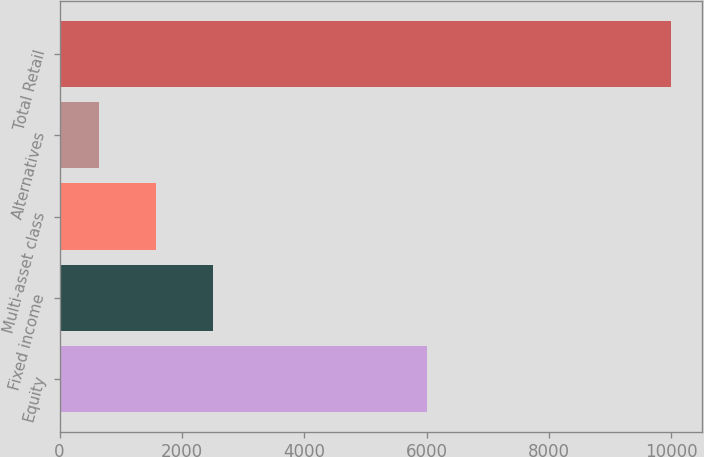Convert chart to OTSL. <chart><loc_0><loc_0><loc_500><loc_500><bar_chart><fcel>Equity<fcel>Fixed income<fcel>Multi-asset class<fcel>Alternatives<fcel>Total Retail<nl><fcel>6003<fcel>2513<fcel>1578<fcel>643<fcel>9993<nl></chart> 